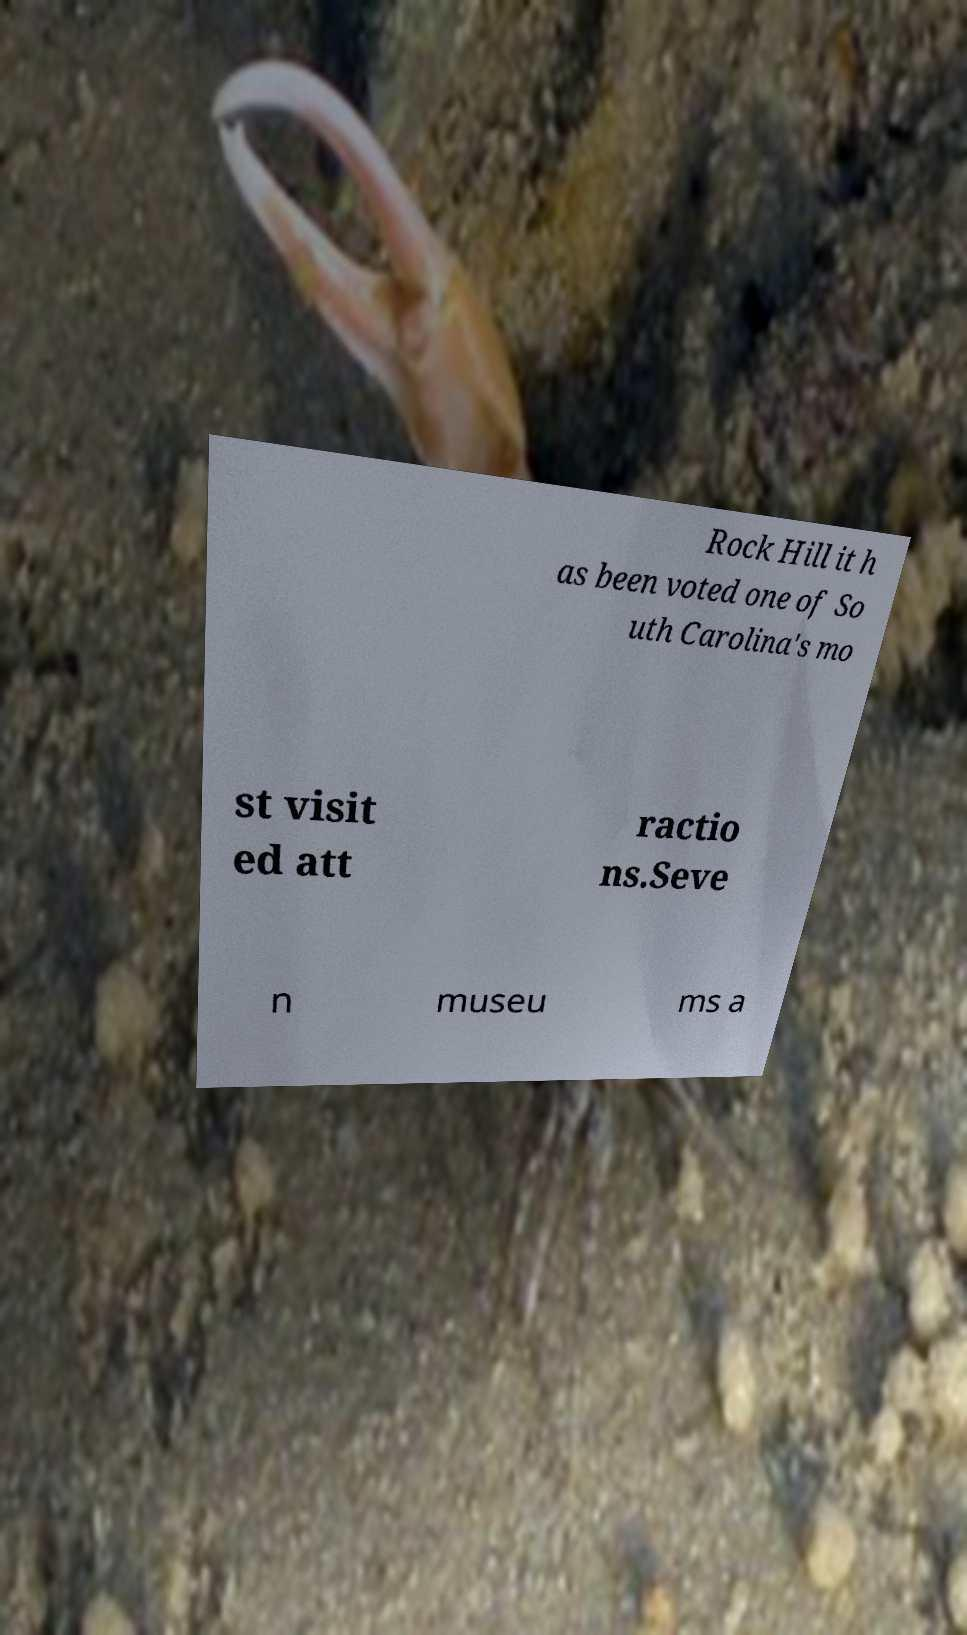What messages or text are displayed in this image? I need them in a readable, typed format. Rock Hill it h as been voted one of So uth Carolina's mo st visit ed att ractio ns.Seve n museu ms a 